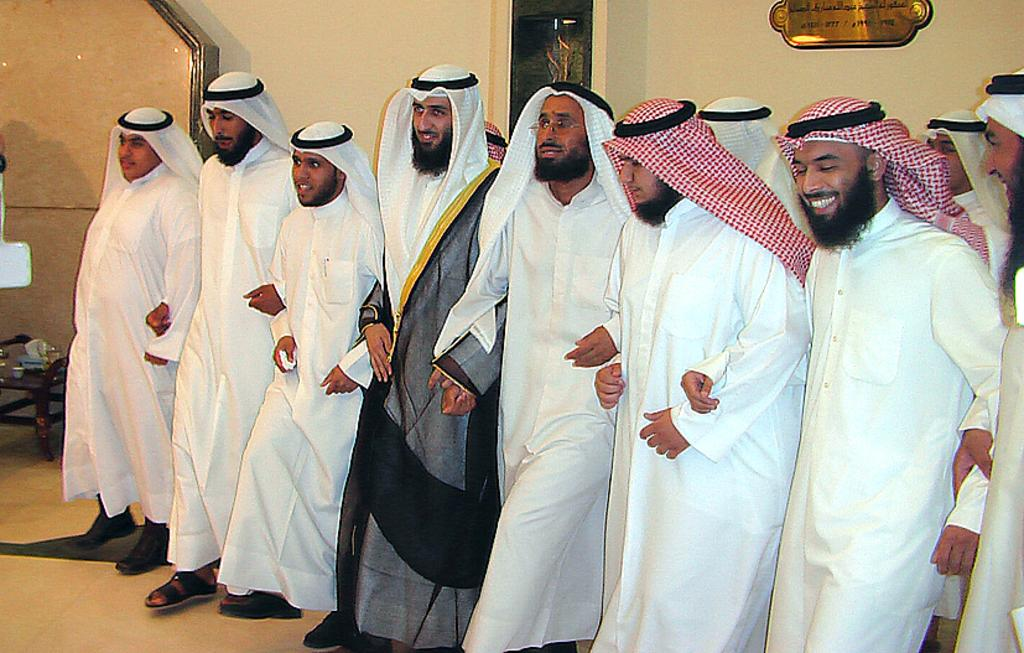What type of clothing are the people wearing in the image? The people in the image are wearing kurtas. What can be seen in the background of the image? There is a wall in the background of the image. Is there anything placed on the wall in the background? Yes, there is a board placed on the wall in the background. What type of wood is used to make the carriage in the image? There is no carriage present in the image; it only features people wearing kurtas and a wall with a board in the background. 